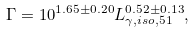<formula> <loc_0><loc_0><loc_500><loc_500>\Gamma = 1 0 ^ { 1 . 6 5 \pm 0 . 2 0 } L _ { \gamma , i s o , 5 1 } ^ { 0 . 5 2 \pm 0 . 1 3 } ,</formula> 